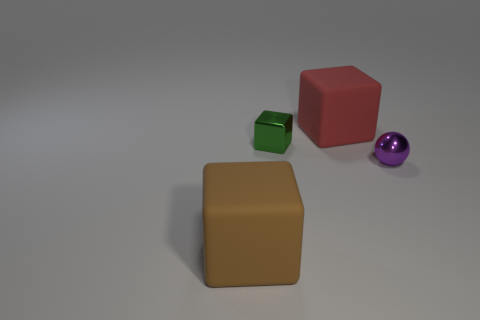What number of objects are either green metallic cylinders or tiny purple shiny spheres?
Offer a very short reply. 1. There is a thing that is made of the same material as the tiny purple ball; what is its shape?
Offer a very short reply. Cube. How many small things are either green things or red matte objects?
Keep it short and to the point. 1. What number of other objects are there of the same color as the tiny sphere?
Your answer should be very brief. 0. How many cubes are in front of the big rubber thing that is on the left side of the big object to the right of the brown matte thing?
Provide a short and direct response. 0. Does the rubber object behind the brown rubber block have the same size as the brown thing?
Make the answer very short. Yes. Are there fewer tiny things that are to the left of the small purple object than balls that are left of the brown thing?
Offer a terse response. No. Does the metallic ball have the same color as the small metallic block?
Your answer should be very brief. No. Is the number of purple metal spheres that are in front of the big red object less than the number of big purple shiny cylinders?
Keep it short and to the point. No. Is the green object made of the same material as the big red block?
Make the answer very short. No. 